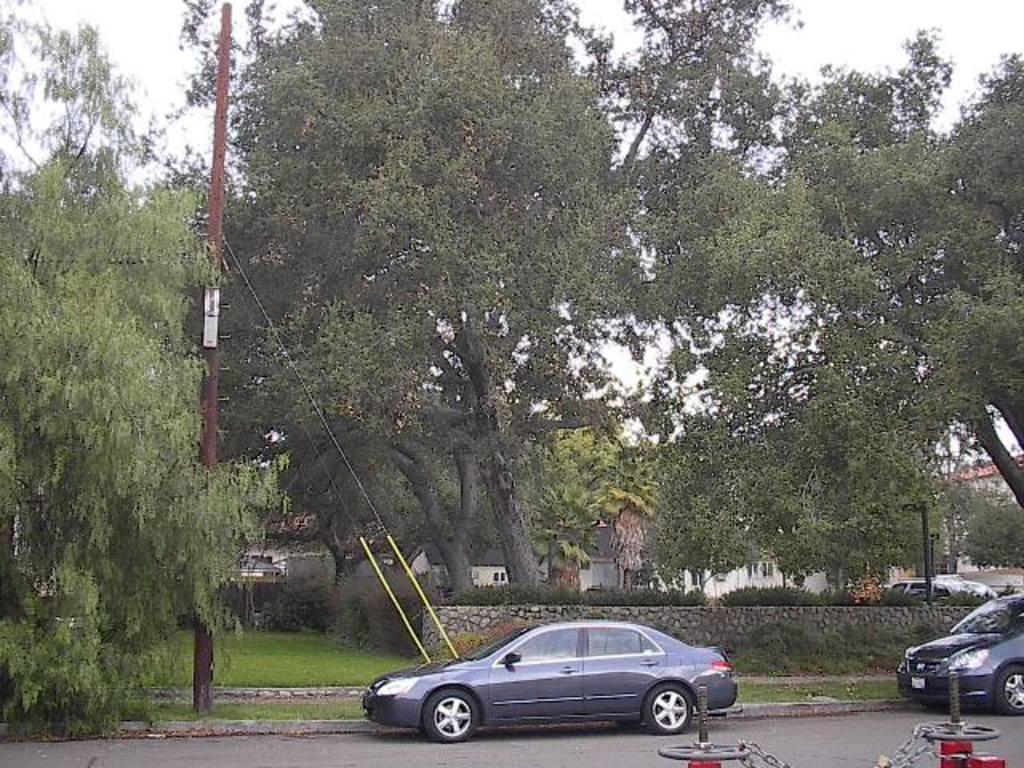Please provide a concise description of this image. In this image I can see few vehicles on the road, in front the vehicle is in gray color. Background I can see trees in green color and sky is in white color. 